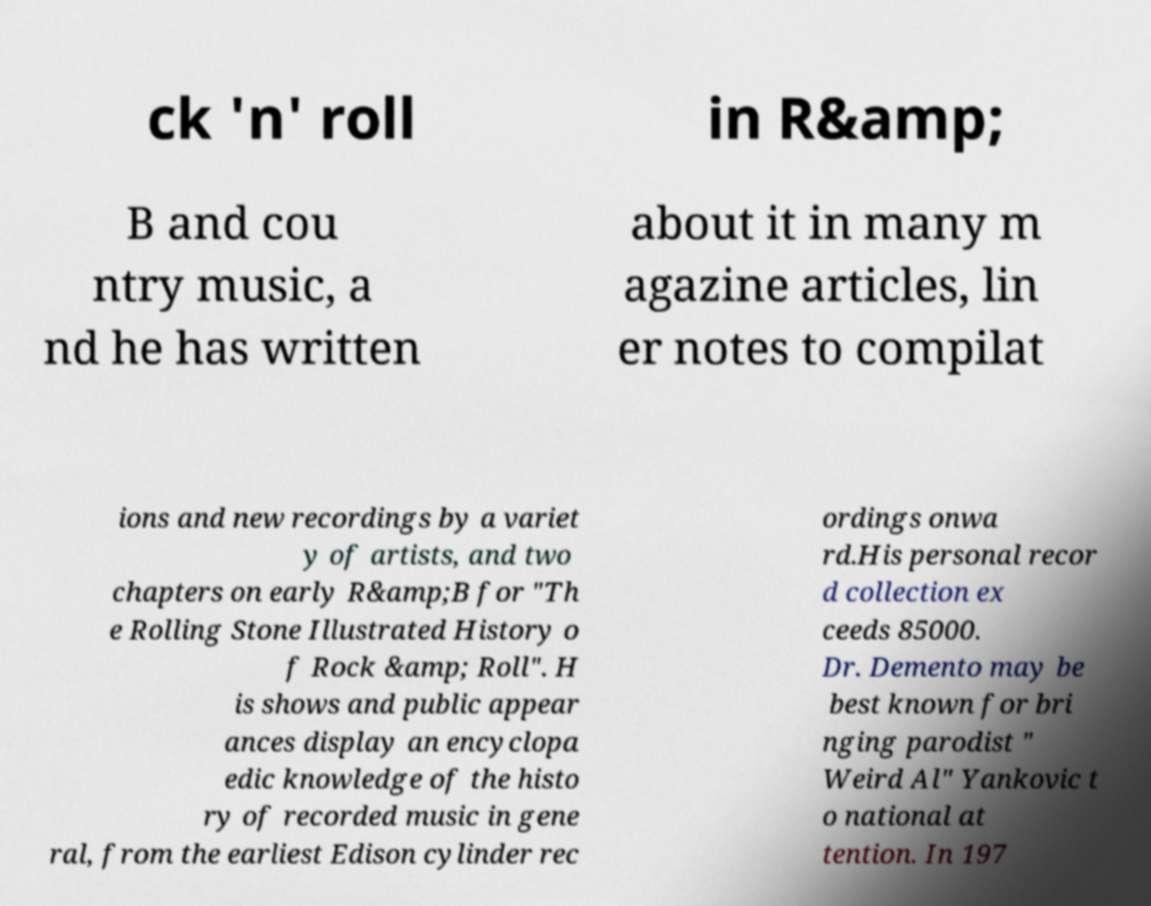Can you read and provide the text displayed in the image?This photo seems to have some interesting text. Can you extract and type it out for me? ck 'n' roll in R&amp; B and cou ntry music, a nd he has written about it in many m agazine articles, lin er notes to compilat ions and new recordings by a variet y of artists, and two chapters on early R&amp;B for "Th e Rolling Stone Illustrated History o f Rock &amp; Roll". H is shows and public appear ances display an encyclopa edic knowledge of the histo ry of recorded music in gene ral, from the earliest Edison cylinder rec ordings onwa rd.His personal recor d collection ex ceeds 85000. Dr. Demento may be best known for bri nging parodist " Weird Al" Yankovic t o national at tention. In 197 